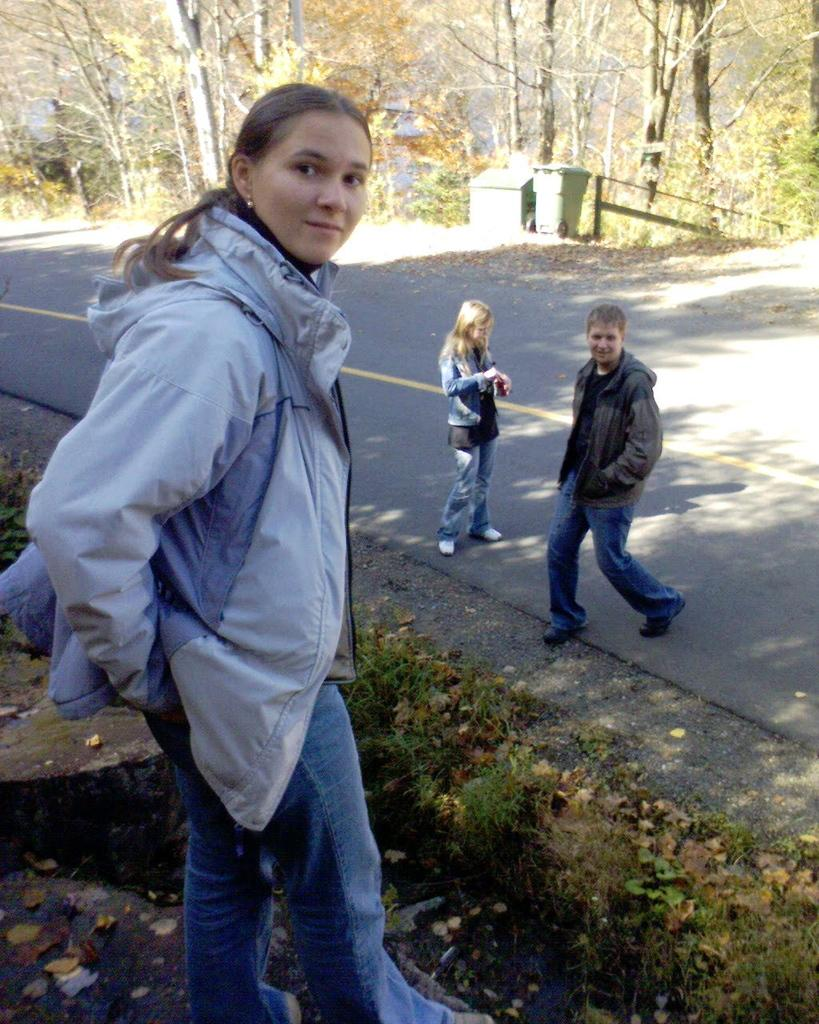Who is on the left side of the image? There is a lady on the left side of the image. How many children are in the image? There is a girl and a boy in the image. What can be seen in the background of the image? There are trees and dustbins in the background of the image. What type of punishment is the army imposing on the children in the image? There is no army or punishment present in the image. What is the reaction of the lady to the boy's actions in the image? There is no indication of the boy's actions or the lady's reaction in the image. 